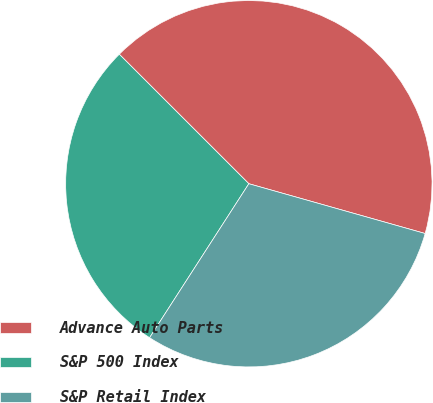Convert chart. <chart><loc_0><loc_0><loc_500><loc_500><pie_chart><fcel>Advance Auto Parts<fcel>S&P 500 Index<fcel>S&P Retail Index<nl><fcel>41.88%<fcel>28.38%<fcel>29.73%<nl></chart> 